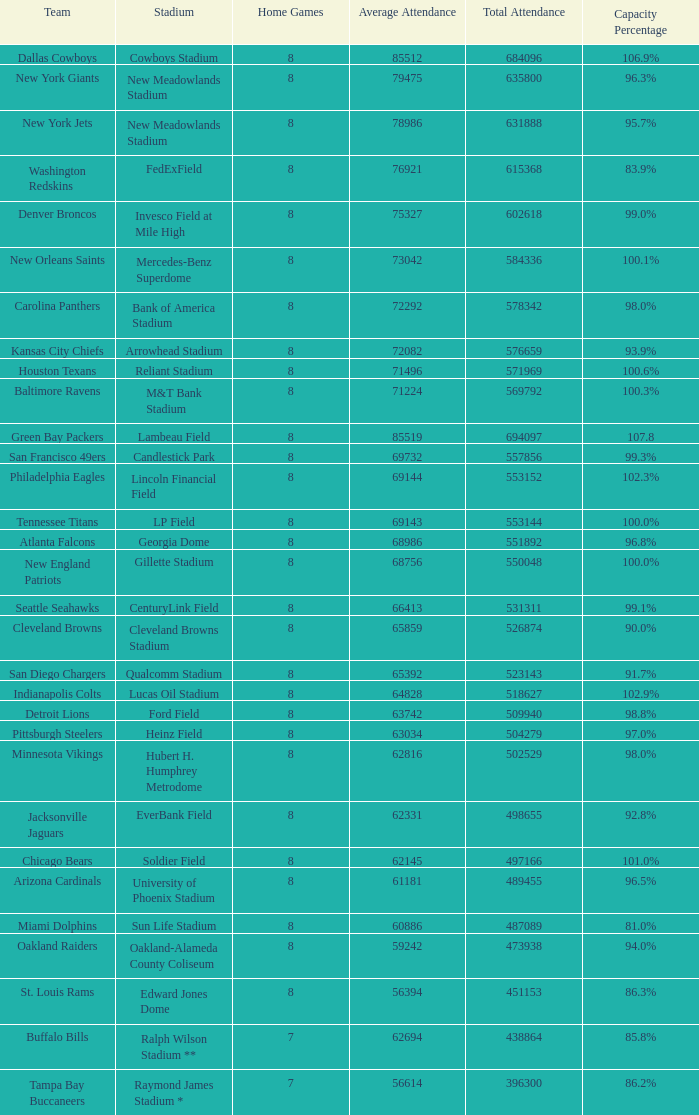What is the proportion of capacity when the complete attendance is 509940? 98.8%. 